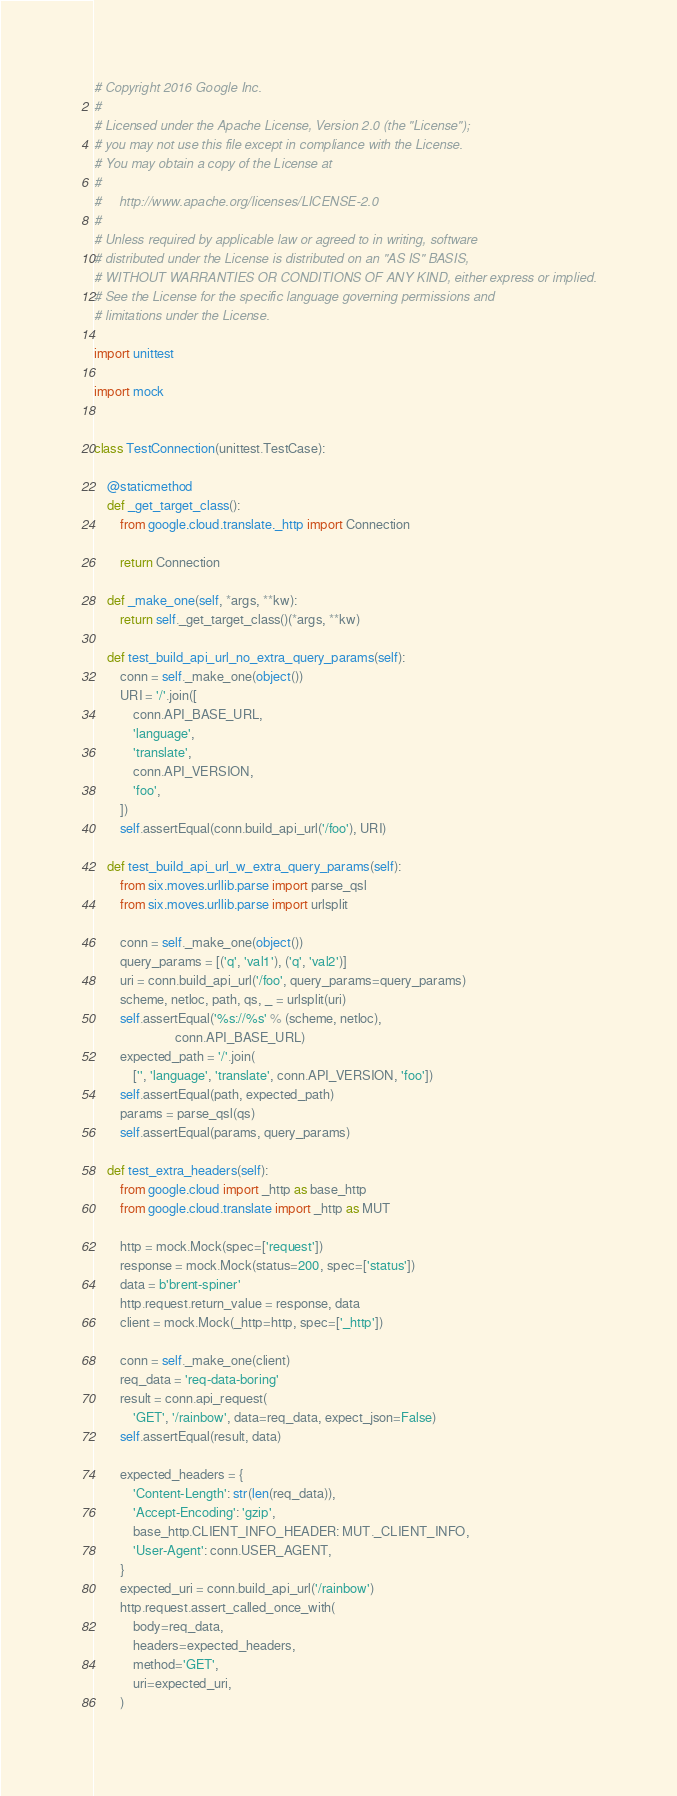<code> <loc_0><loc_0><loc_500><loc_500><_Python_># Copyright 2016 Google Inc.
#
# Licensed under the Apache License, Version 2.0 (the "License");
# you may not use this file except in compliance with the License.
# You may obtain a copy of the License at
#
#     http://www.apache.org/licenses/LICENSE-2.0
#
# Unless required by applicable law or agreed to in writing, software
# distributed under the License is distributed on an "AS IS" BASIS,
# WITHOUT WARRANTIES OR CONDITIONS OF ANY KIND, either express or implied.
# See the License for the specific language governing permissions and
# limitations under the License.

import unittest

import mock


class TestConnection(unittest.TestCase):

    @staticmethod
    def _get_target_class():
        from google.cloud.translate._http import Connection

        return Connection

    def _make_one(self, *args, **kw):
        return self._get_target_class()(*args, **kw)

    def test_build_api_url_no_extra_query_params(self):
        conn = self._make_one(object())
        URI = '/'.join([
            conn.API_BASE_URL,
            'language',
            'translate',
            conn.API_VERSION,
            'foo',
        ])
        self.assertEqual(conn.build_api_url('/foo'), URI)

    def test_build_api_url_w_extra_query_params(self):
        from six.moves.urllib.parse import parse_qsl
        from six.moves.urllib.parse import urlsplit

        conn = self._make_one(object())
        query_params = [('q', 'val1'), ('q', 'val2')]
        uri = conn.build_api_url('/foo', query_params=query_params)
        scheme, netloc, path, qs, _ = urlsplit(uri)
        self.assertEqual('%s://%s' % (scheme, netloc),
                         conn.API_BASE_URL)
        expected_path = '/'.join(
            ['', 'language', 'translate', conn.API_VERSION, 'foo'])
        self.assertEqual(path, expected_path)
        params = parse_qsl(qs)
        self.assertEqual(params, query_params)

    def test_extra_headers(self):
        from google.cloud import _http as base_http
        from google.cloud.translate import _http as MUT

        http = mock.Mock(spec=['request'])
        response = mock.Mock(status=200, spec=['status'])
        data = b'brent-spiner'
        http.request.return_value = response, data
        client = mock.Mock(_http=http, spec=['_http'])

        conn = self._make_one(client)
        req_data = 'req-data-boring'
        result = conn.api_request(
            'GET', '/rainbow', data=req_data, expect_json=False)
        self.assertEqual(result, data)

        expected_headers = {
            'Content-Length': str(len(req_data)),
            'Accept-Encoding': 'gzip',
            base_http.CLIENT_INFO_HEADER: MUT._CLIENT_INFO,
            'User-Agent': conn.USER_AGENT,
        }
        expected_uri = conn.build_api_url('/rainbow')
        http.request.assert_called_once_with(
            body=req_data,
            headers=expected_headers,
            method='GET',
            uri=expected_uri,
        )
</code> 